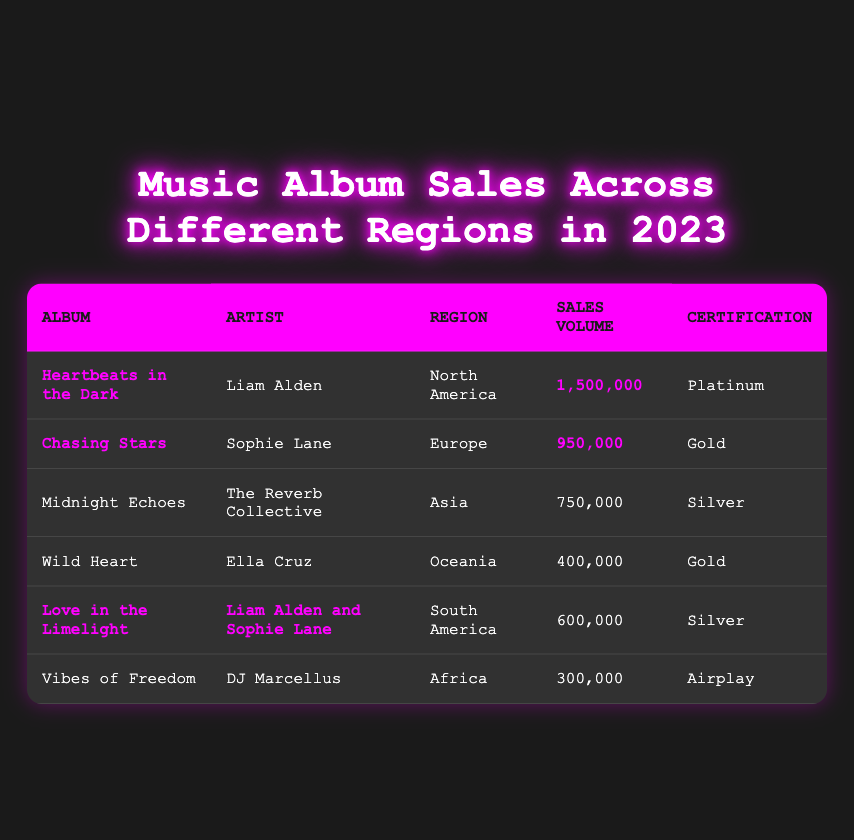What is the total sales volume for all albums in 2023? To find the total sales volume, add the sales volume of each album: 1,500,000 + 950,000 + 750,000 + 400,000 + 600,000 + 300,000 = 4,500,000.
Answer: 4,500,000 Which album has the highest sales volume? By examining the sales volume for each album, "Heartbeats in the Dark" has the highest sales volume at 1,500,000.
Answer: Heartbeats in the Dark How many albums received a Gold certification? The albums with a Gold certification are "Chasing Stars" and "Wild Heart," so there are 2 albums with this certification.
Answer: 2 Is "Midnight Echoes" certified Platinum? "Midnight Echoes" has a certification of Silver, so it is not certified Platinum.
Answer: No What is the average sales volume of albums certified Silver? The albums certified Silver are "Midnight Echoes" and "Love in the Limelight." Their sales volumes are 750,000 and 600,000, respectively. The average is (750,000 + 600,000) / 2 = 675,000.
Answer: 675,000 Which region had the lowest sales volume for albums? The album "Vibes of Freedom" in Africa has the lowest sales volume at 300,000.
Answer: Africa Did any album by Liam Alden provide higher sales than all others combined in South America? The album "Love in the Limelight" by Liam Alden and Sophie Lane had sales of 600,000; in South America, the combined total from all albums is 600,000, matching it but not exceeding it.
Answer: No Which artist has the highest combined sales across all regions? Liam Alden has sales of 1,500,000 (Heartbeats in the Dark) and 600,000 (Love in the Limelight), totaling 2,100,000. Sophie Lane has 950,000 and 600,000 totaling 1,550,000, The Reverb Collective has 750,000, Ella Cruz has 400,000, and DJ Marcellus has 300,000, showing that Liam Alden has the highest combined sales.
Answer: Liam Alden What proportion of total sales volume is attributed to albums certified Platinum? The only Platinum album is "Heartbeats in the Dark" with sales of 1,500,000. Thus, the proportion is 1,500,000 / 4,500,000 = 1/3, or approximately 33.33%.
Answer: 33.33% How many albums have a sales volume greater than 500,000? The albums with sales volumes greater than 500,000 are "Heartbeats in the Dark," "Chasing Stars," and "Midnight Echoes," totaling 3 albums.
Answer: 3 